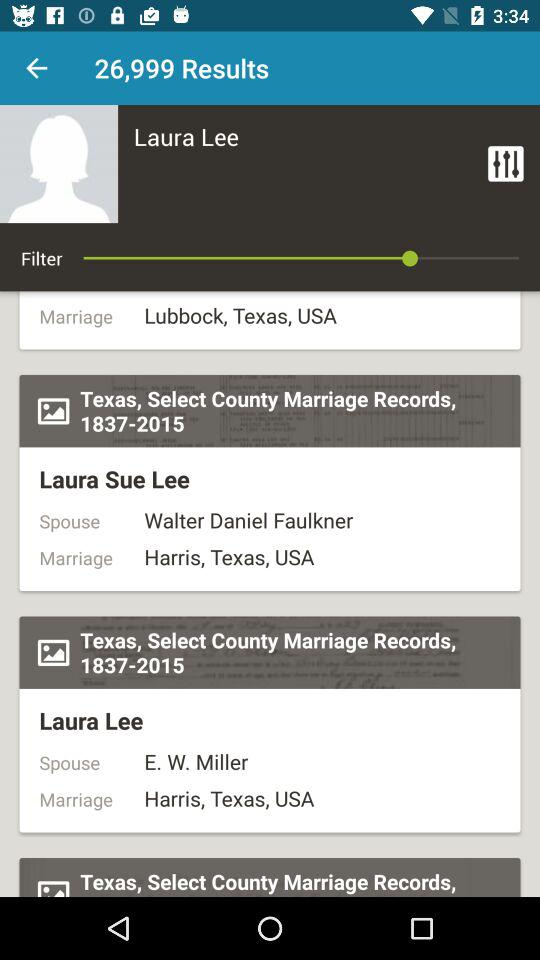How many results are shown? There are 26999 results shown. 